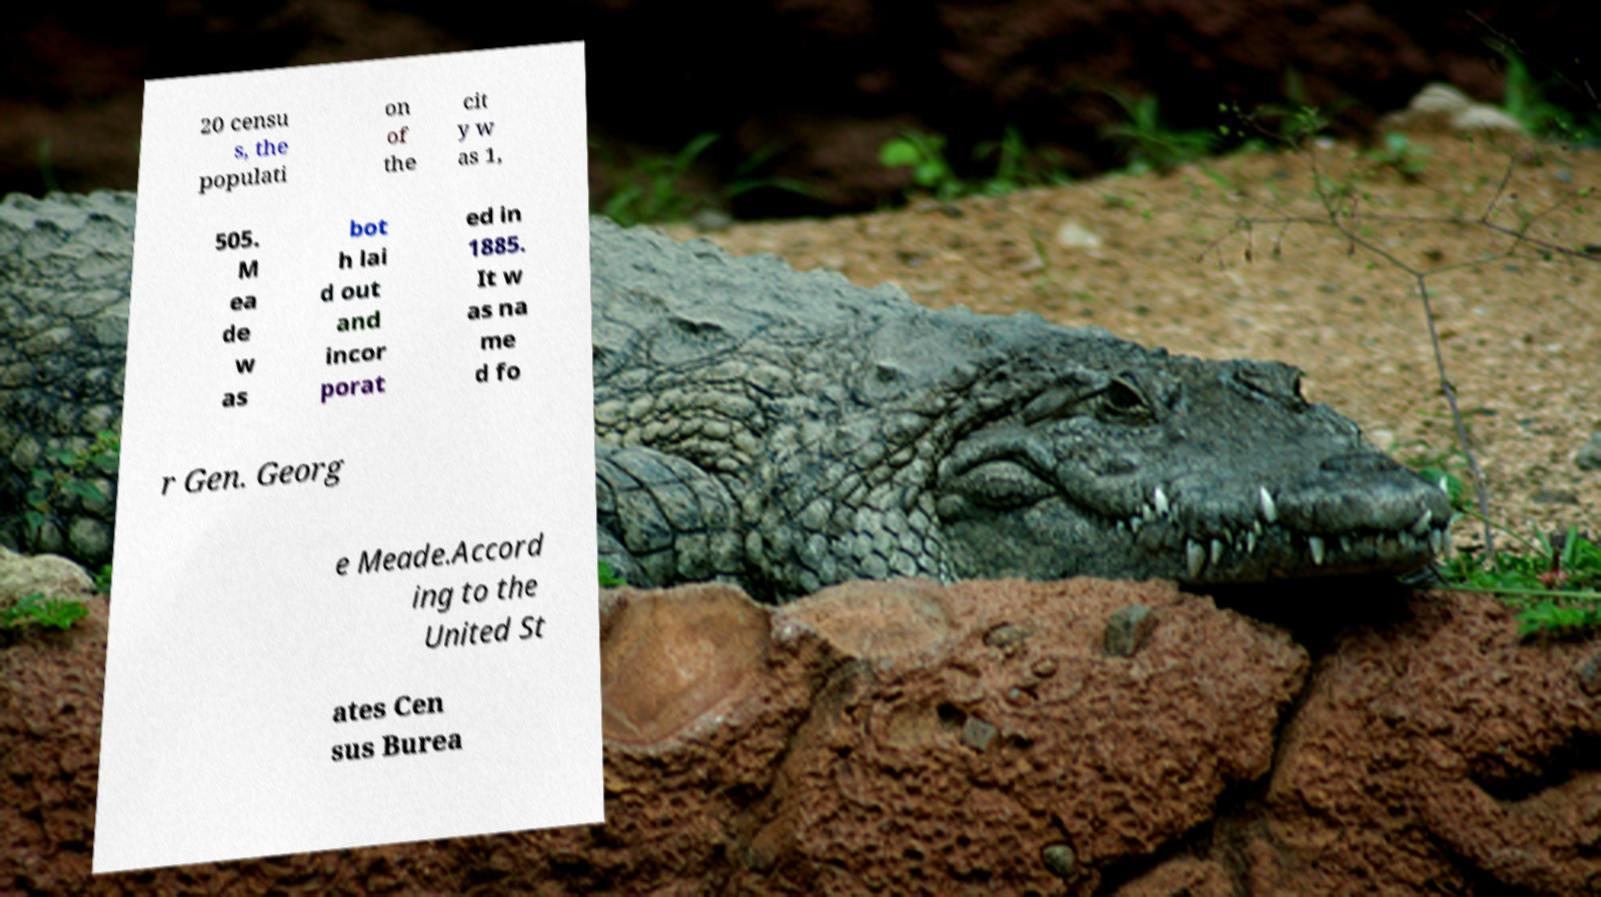What messages or text are displayed in this image? I need them in a readable, typed format. 20 censu s, the populati on of the cit y w as 1, 505. M ea de w as bot h lai d out and incor porat ed in 1885. It w as na me d fo r Gen. Georg e Meade.Accord ing to the United St ates Cen sus Burea 